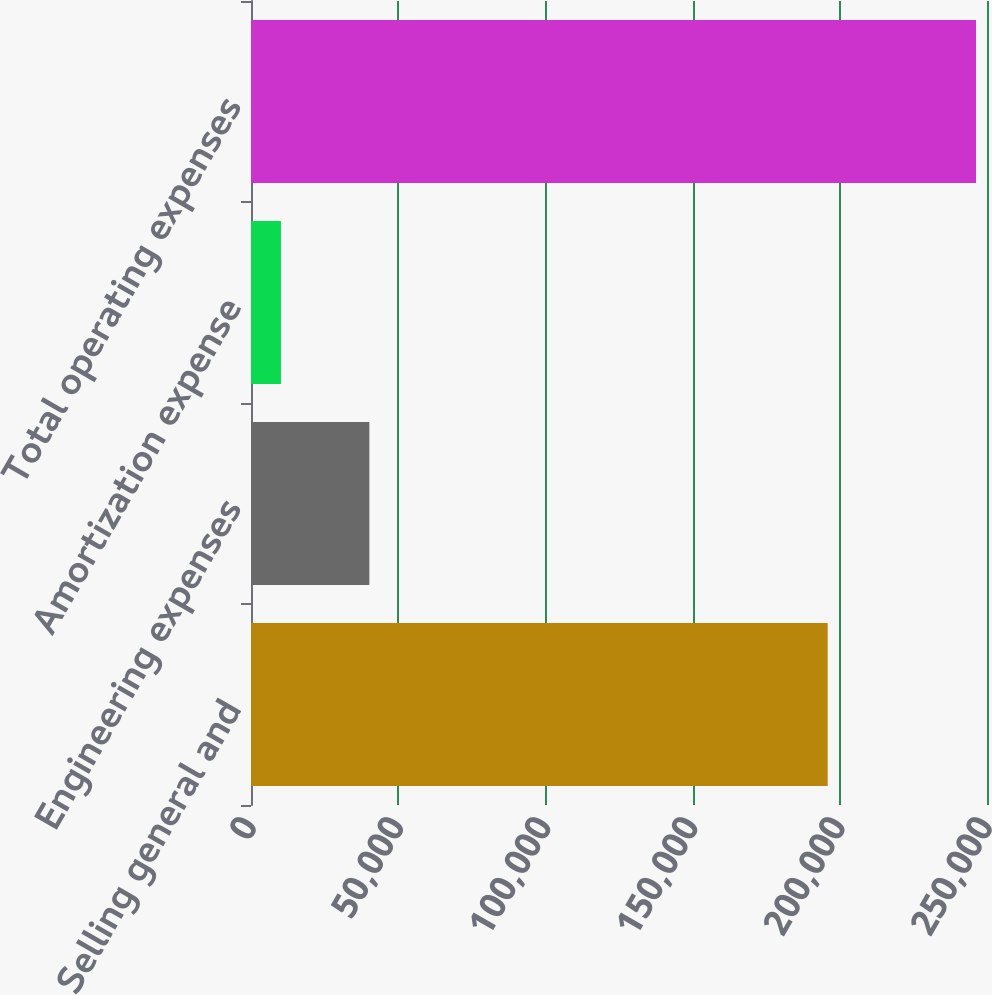<chart> <loc_0><loc_0><loc_500><loc_500><bar_chart><fcel>Selling general and<fcel>Engineering expenses<fcel>Amortization expense<fcel>Total operating expenses<nl><fcel>195892<fcel>40203<fcel>10173<fcel>246268<nl></chart> 